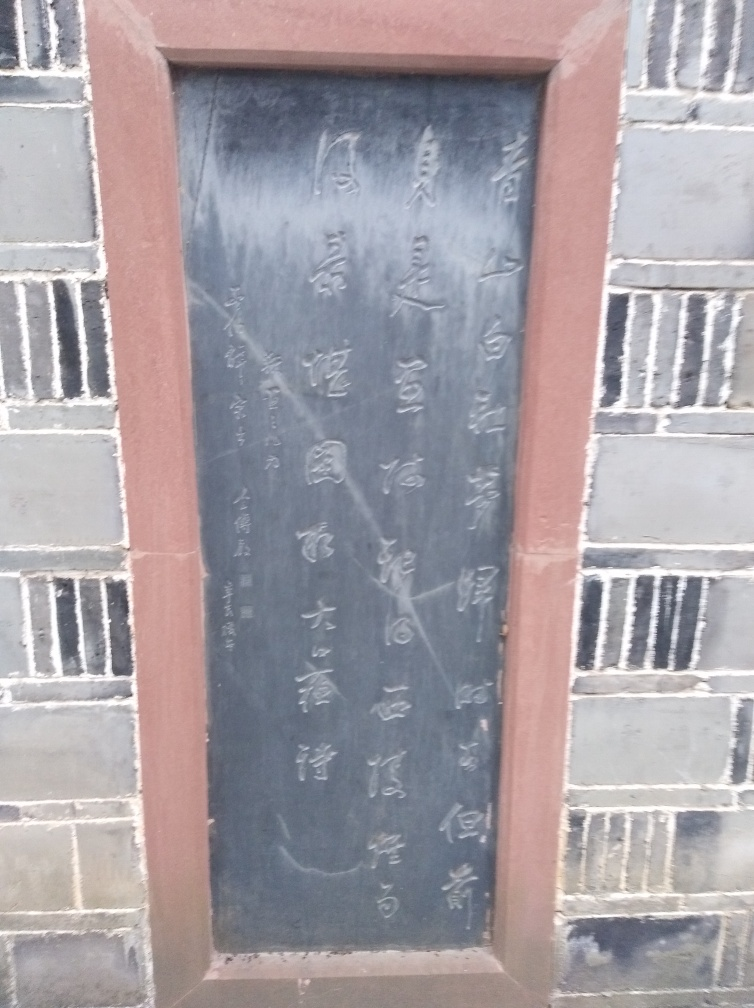What is the clarity of this photo?
A. Low.
B. Medium.
C. High. The clarity of the photograph is medium. The image appears somewhat blurred, making the details, such as the inscriptions on the stone tablet, not as sharp or distinct as they could be in high clarity photographs. The focus is not as crisp, and elements have a softness to their edges. 